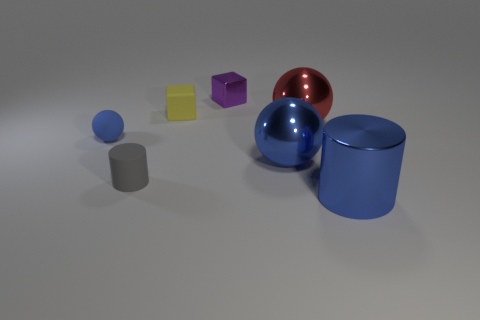There is a ball behind the small object to the left of the cylinder that is to the left of the tiny purple shiny cube; what is its size?
Your response must be concise. Large. What is the material of the purple block?
Offer a very short reply. Metal. Is the large cylinder made of the same material as the blue sphere in front of the blue rubber ball?
Ensure brevity in your answer.  Yes. Are there any other things that have the same color as the matte block?
Your answer should be compact. No. Are there any large blue cylinders behind the blue ball that is to the left of the rubber thing behind the small blue sphere?
Keep it short and to the point. No. The big metal cylinder is what color?
Your answer should be compact. Blue. There is a gray object; are there any blue spheres on the right side of it?
Provide a succinct answer. Yes. Do the purple metal object and the object in front of the small gray cylinder have the same shape?
Offer a terse response. No. What number of other objects are there of the same material as the purple object?
Offer a very short reply. 3. There is a small rubber thing behind the big ball that is behind the ball on the left side of the tiny yellow object; what color is it?
Offer a very short reply. Yellow. 